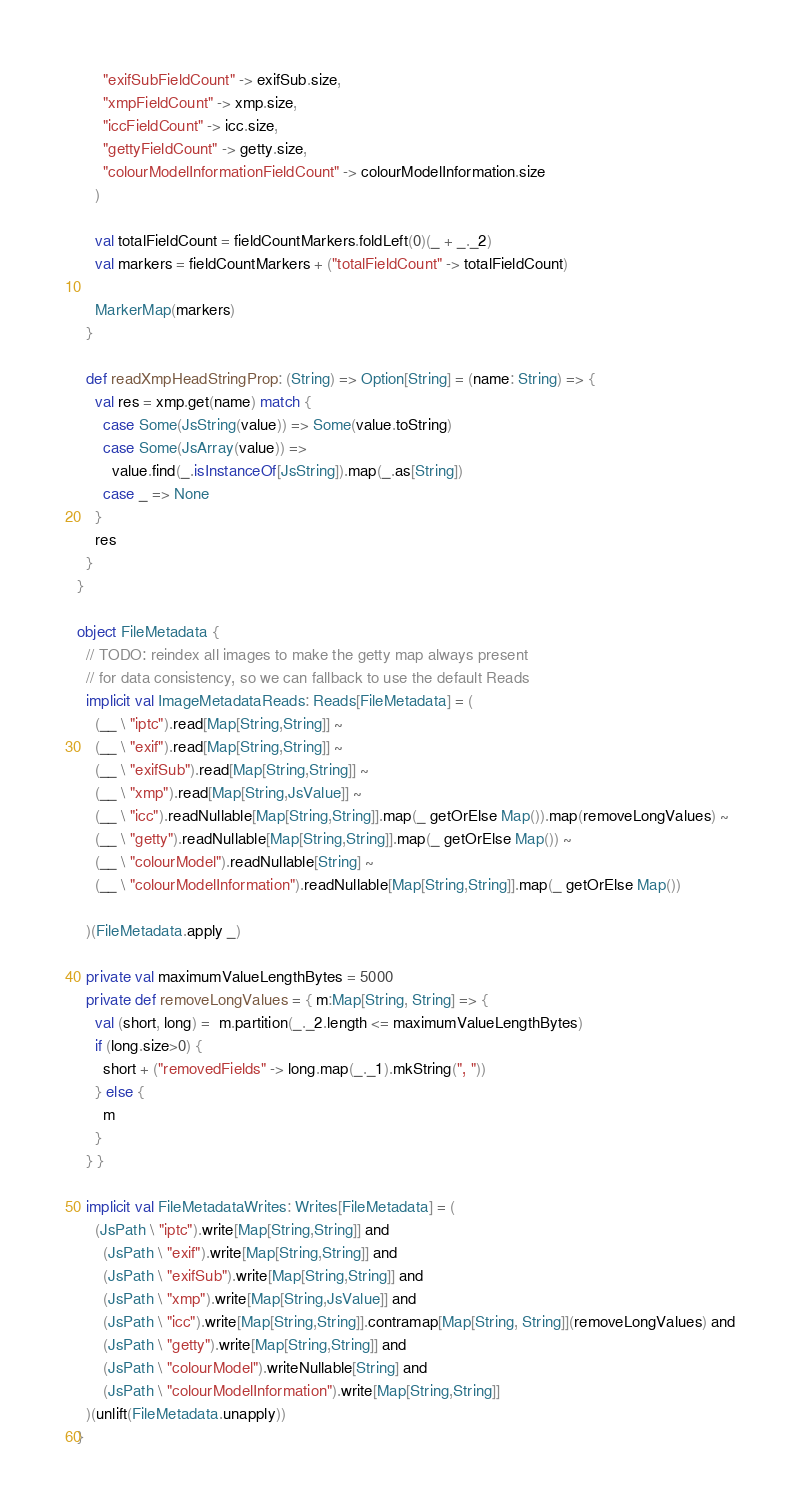<code> <loc_0><loc_0><loc_500><loc_500><_Scala_>      "exifSubFieldCount" -> exifSub.size,
      "xmpFieldCount" -> xmp.size,
      "iccFieldCount" -> icc.size,
      "gettyFieldCount" -> getty.size,
      "colourModelInformationFieldCount" -> colourModelInformation.size
    )

    val totalFieldCount = fieldCountMarkers.foldLeft(0)(_ + _._2)
    val markers = fieldCountMarkers + ("totalFieldCount" -> totalFieldCount)

    MarkerMap(markers)
  }

  def readXmpHeadStringProp: (String) => Option[String] = (name: String) => {
    val res = xmp.get(name) match {
      case Some(JsString(value)) => Some(value.toString)
      case Some(JsArray(value)) =>
        value.find(_.isInstanceOf[JsString]).map(_.as[String])
      case _ => None
    }
    res
  }
}

object FileMetadata {
  // TODO: reindex all images to make the getty map always present
  // for data consistency, so we can fallback to use the default Reads
  implicit val ImageMetadataReads: Reads[FileMetadata] = (
    (__ \ "iptc").read[Map[String,String]] ~
    (__ \ "exif").read[Map[String,String]] ~
    (__ \ "exifSub").read[Map[String,String]] ~
    (__ \ "xmp").read[Map[String,JsValue]] ~
    (__ \ "icc").readNullable[Map[String,String]].map(_ getOrElse Map()).map(removeLongValues) ~
    (__ \ "getty").readNullable[Map[String,String]].map(_ getOrElse Map()) ~
    (__ \ "colourModel").readNullable[String] ~
    (__ \ "colourModelInformation").readNullable[Map[String,String]].map(_ getOrElse Map())

  )(FileMetadata.apply _)

  private val maximumValueLengthBytes = 5000
  private def removeLongValues = { m:Map[String, String] => {
    val (short, long) =  m.partition(_._2.length <= maximumValueLengthBytes)
    if (long.size>0) {
      short + ("removedFields" -> long.map(_._1).mkString(", "))
    } else {
      m
    }
  } }

  implicit val FileMetadataWrites: Writes[FileMetadata] = (
    (JsPath \ "iptc").write[Map[String,String]] and
      (JsPath \ "exif").write[Map[String,String]] and
      (JsPath \ "exifSub").write[Map[String,String]] and
      (JsPath \ "xmp").write[Map[String,JsValue]] and
      (JsPath \ "icc").write[Map[String,String]].contramap[Map[String, String]](removeLongValues) and
      (JsPath \ "getty").write[Map[String,String]] and
      (JsPath \ "colourModel").writeNullable[String] and
      (JsPath \ "colourModelInformation").write[Map[String,String]]
  )(unlift(FileMetadata.unapply))
}
</code> 